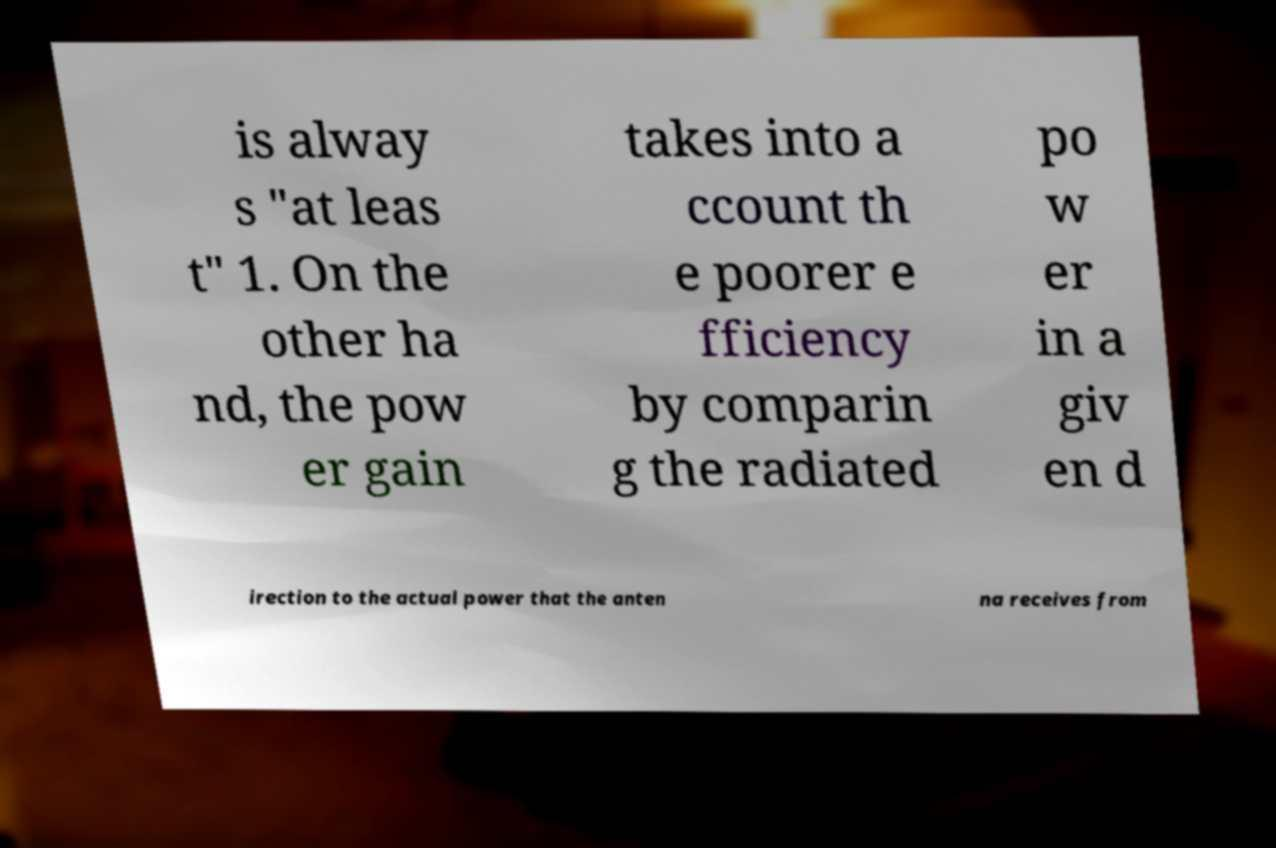Could you assist in decoding the text presented in this image and type it out clearly? is alway s "at leas t" 1. On the other ha nd, the pow er gain takes into a ccount th e poorer e fficiency by comparin g the radiated po w er in a giv en d irection to the actual power that the anten na receives from 